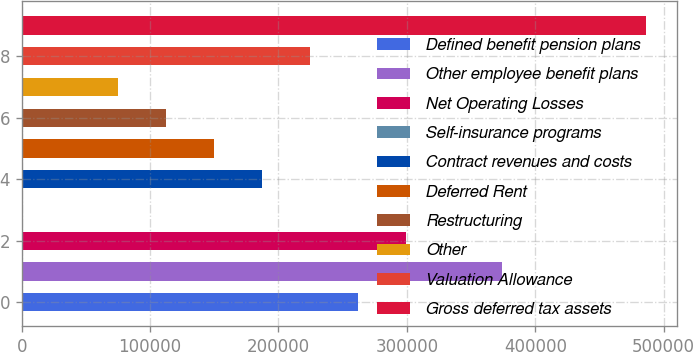Convert chart. <chart><loc_0><loc_0><loc_500><loc_500><bar_chart><fcel>Defined benefit pension plans<fcel>Other employee benefit plans<fcel>Net Operating Losses<fcel>Self-insurance programs<fcel>Contract revenues and costs<fcel>Deferred Rent<fcel>Restructuring<fcel>Other<fcel>Valuation Allowance<fcel>Gross deferred tax assets<nl><fcel>261987<fcel>374064<fcel>299346<fcel>473<fcel>187268<fcel>149909<fcel>112550<fcel>75191.2<fcel>224628<fcel>486141<nl></chart> 